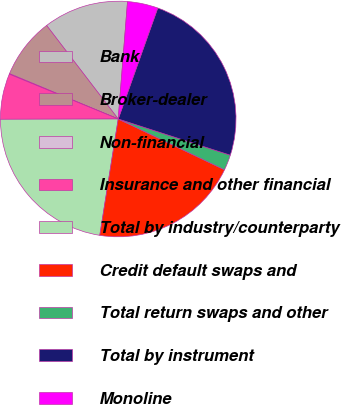Convert chart to OTSL. <chart><loc_0><loc_0><loc_500><loc_500><pie_chart><fcel>Bank<fcel>Broker-dealer<fcel>Non-financial<fcel>Insurance and other financial<fcel>Total by industry/counterparty<fcel>Credit default swaps and<fcel>Total return swaps and other<fcel>Total by instrument<fcel>Monoline<nl><fcel>11.66%<fcel>8.31%<fcel>0.08%<fcel>6.25%<fcel>22.46%<fcel>20.4%<fcel>2.13%<fcel>24.52%<fcel>4.19%<nl></chart> 